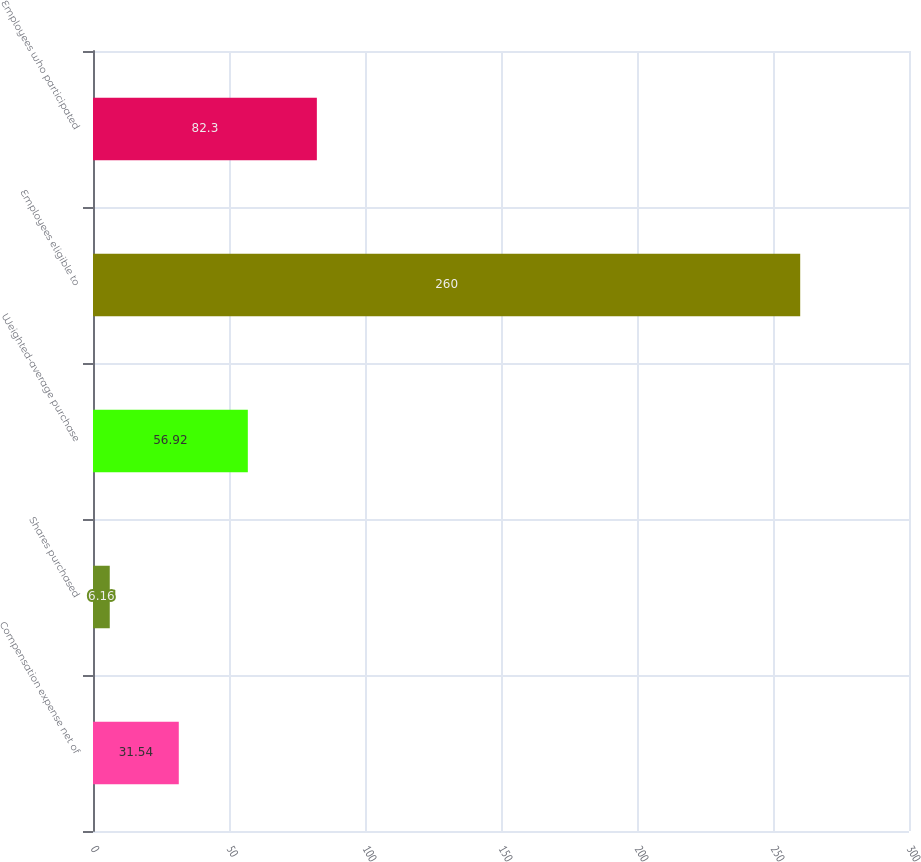Convert chart to OTSL. <chart><loc_0><loc_0><loc_500><loc_500><bar_chart><fcel>Compensation expense net of<fcel>Shares purchased<fcel>Weighted-average purchase<fcel>Employees eligible to<fcel>Employees who participated<nl><fcel>31.54<fcel>6.16<fcel>56.92<fcel>260<fcel>82.3<nl></chart> 